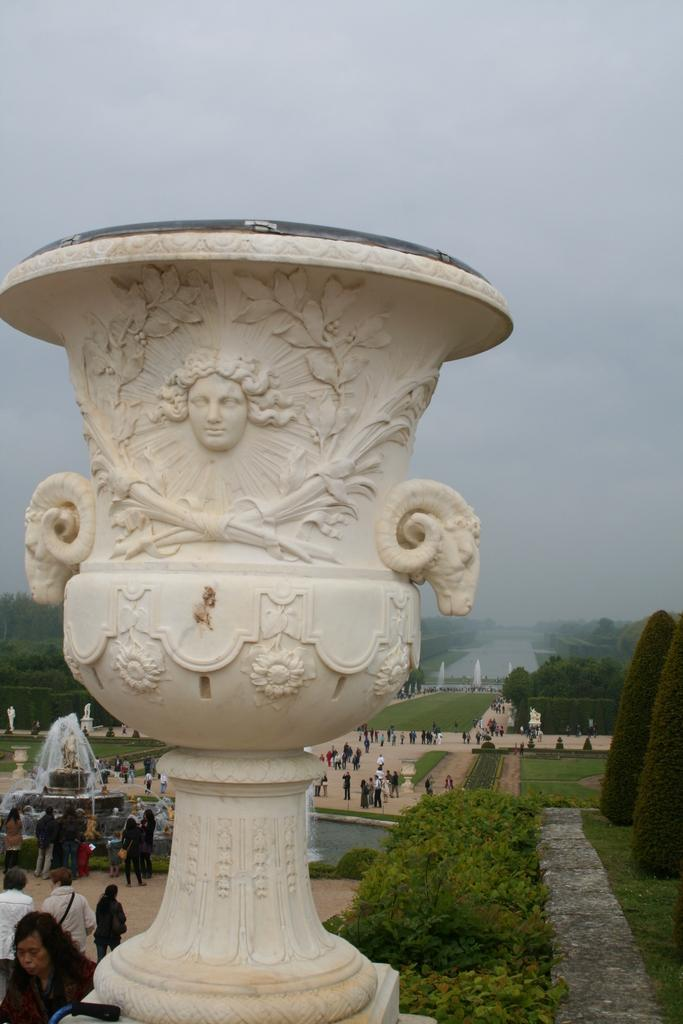What is the main subject of the image? There is a sculpture in the image. What else can be seen in the background of the image? There are people standing in the background of the image. What type of water feature is present in the image? There are fountains in the image. What type of vegetation is present in the image? There are trees in the image. What is visible in the sky in the image? The sky is visible in the image. What type of zipper can be seen on the sculpture in the image? There is no zipper present on the sculpture in the image. Who is the expert standing next to the sculpture in the image? There is no expert identified in the image, and no one is specifically standing next to the sculpture. 